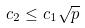<formula> <loc_0><loc_0><loc_500><loc_500>c _ { 2 } \leq c _ { 1 } \sqrt { p }</formula> 